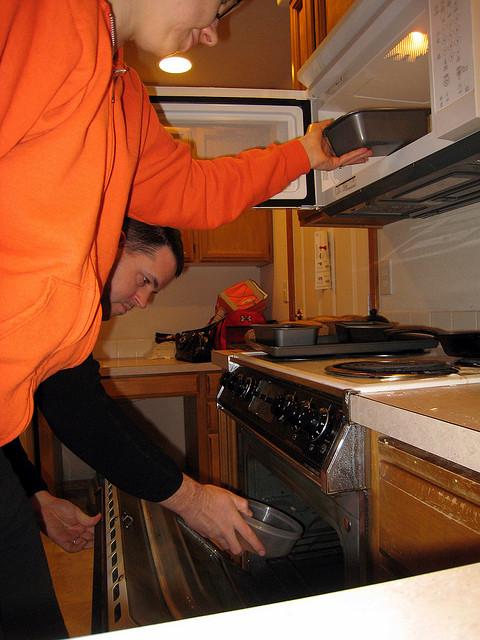Are these people in each others way?
Give a very brief answer. Yes. What color are the cabinets?
Give a very brief answer. Brown. What hand is the man in orange using?
Concise answer only. Left. 